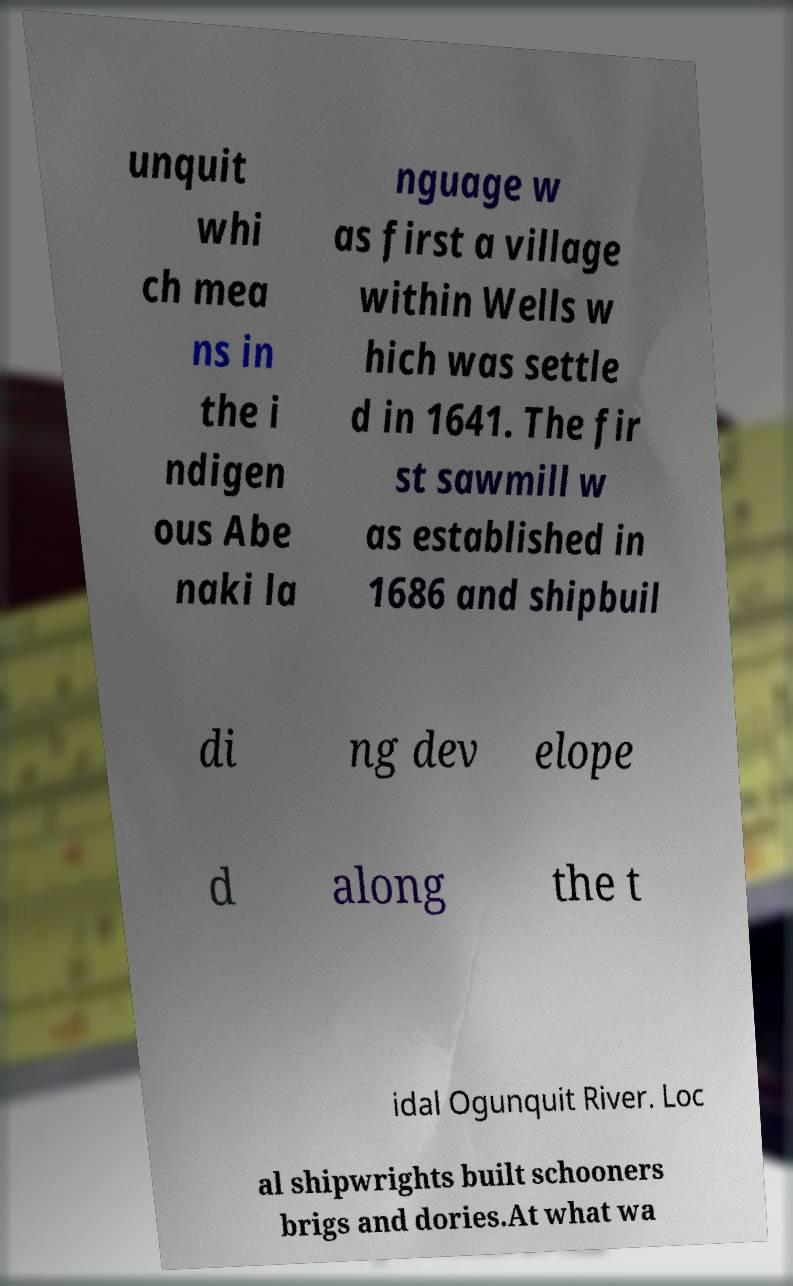For documentation purposes, I need the text within this image transcribed. Could you provide that? unquit whi ch mea ns in the i ndigen ous Abe naki la nguage w as first a village within Wells w hich was settle d in 1641. The fir st sawmill w as established in 1686 and shipbuil di ng dev elope d along the t idal Ogunquit River. Loc al shipwrights built schooners brigs and dories.At what wa 